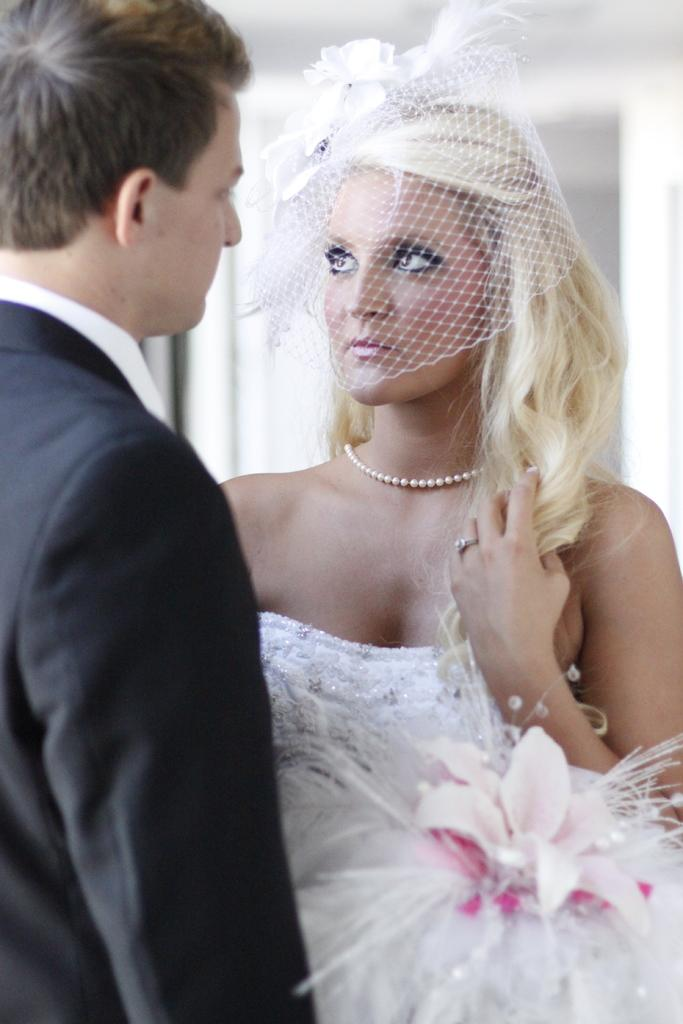What is happening between the two people in the image? There is a couple standing in the image, and they are staring at each other. What is located behind the couple? There is a wall behind the couple. What part of the room can be seen at the top of the image? The ceiling is visible at the top of the image. What type of force is being applied to the gate in the image? There is no gate present in the image; it features a couple standing and staring at each other. What color is the skirt worn by the woman in the image? There is no woman wearing a skirt in the image; it features a couple, both of whom appear to be dressed in pants or trousers. 